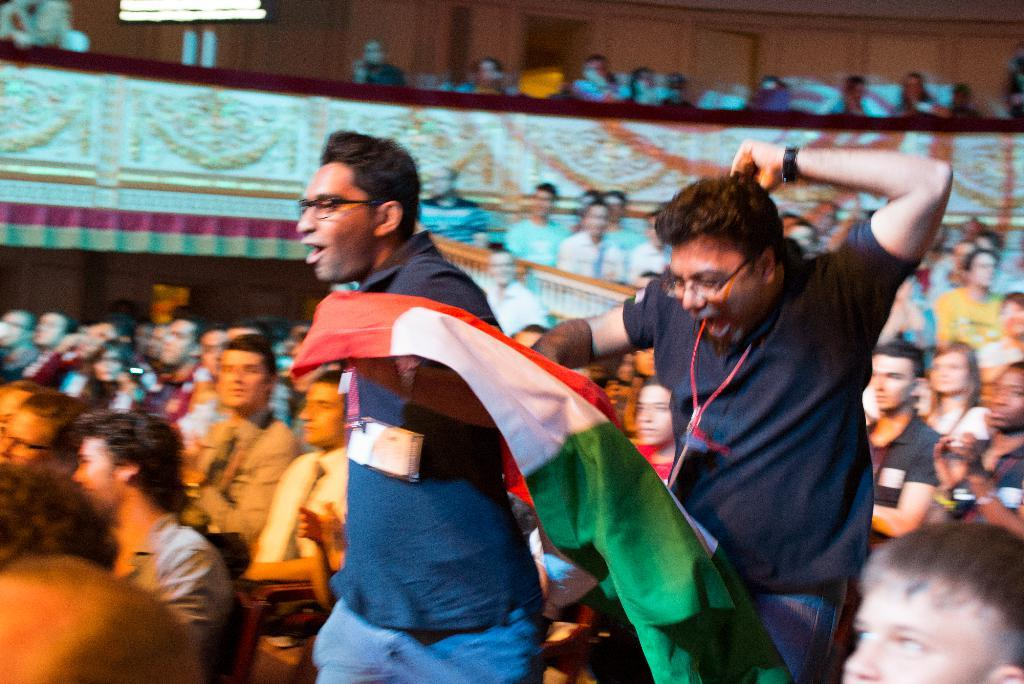How many people are in the image? There is a group of people in the image, but the exact number cannot be determined from the provided facts. What can be seen in the image besides the group of people? There is a flag and a wall in the image, as well as objects. Can you describe the flag in the image? Unfortunately, the provided facts do not give any information about the flag's appearance or design. What type of objects are present in the image? The provided facts do not specify the type of objects in the image. What type of meat is being grilled by the uncle in the image? There is no uncle or meat present in the image, so this question cannot be answered. 